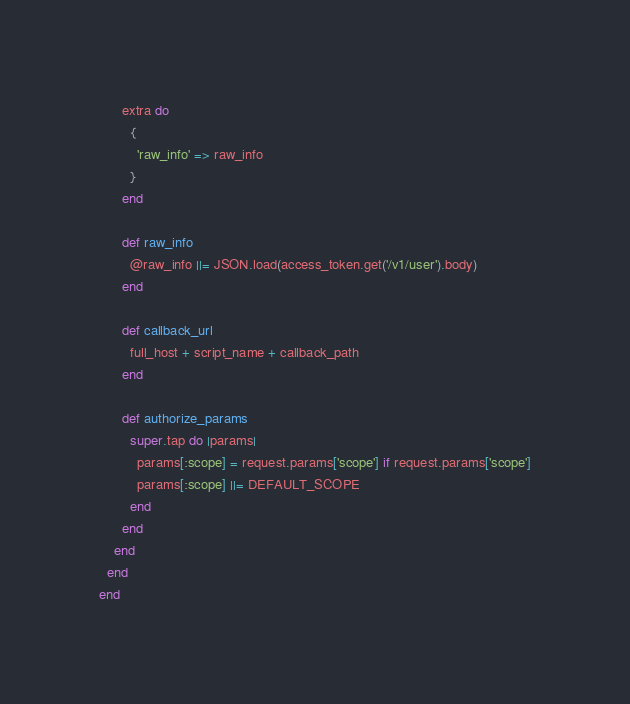Convert code to text. <code><loc_0><loc_0><loc_500><loc_500><_Ruby_>      extra do
        {
          'raw_info' => raw_info
        }
      end

      def raw_info
        @raw_info ||= JSON.load(access_token.get('/v1/user').body)
      end

      def callback_url
        full_host + script_name + callback_path
      end

      def authorize_params
        super.tap do |params|
          params[:scope] = request.params['scope'] if request.params['scope']
          params[:scope] ||= DEFAULT_SCOPE
        end
      end
    end
  end
end
</code> 